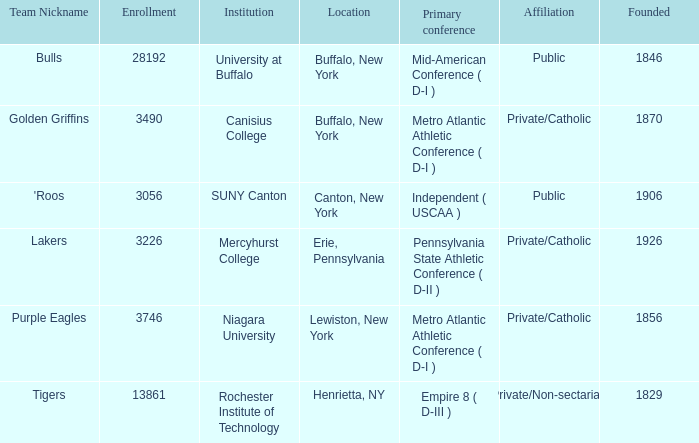What kind of school is Canton, New York? Public. Could you parse the entire table as a dict? {'header': ['Team Nickname', 'Enrollment', 'Institution', 'Location', 'Primary conference', 'Affiliation', 'Founded'], 'rows': [['Bulls', '28192', 'University at Buffalo', 'Buffalo, New York', 'Mid-American Conference ( D-I )', 'Public', '1846'], ['Golden Griffins', '3490', 'Canisius College', 'Buffalo, New York', 'Metro Atlantic Athletic Conference ( D-I )', 'Private/Catholic', '1870'], ["'Roos", '3056', 'SUNY Canton', 'Canton, New York', 'Independent ( USCAA )', 'Public', '1906'], ['Lakers', '3226', 'Mercyhurst College', 'Erie, Pennsylvania', 'Pennsylvania State Athletic Conference ( D-II )', 'Private/Catholic', '1926'], ['Purple Eagles', '3746', 'Niagara University', 'Lewiston, New York', 'Metro Atlantic Athletic Conference ( D-I )', 'Private/Catholic', '1856'], ['Tigers', '13861', 'Rochester Institute of Technology', 'Henrietta, NY', 'Empire 8 ( D-III )', 'Private/Non-sectarian', '1829']]} 